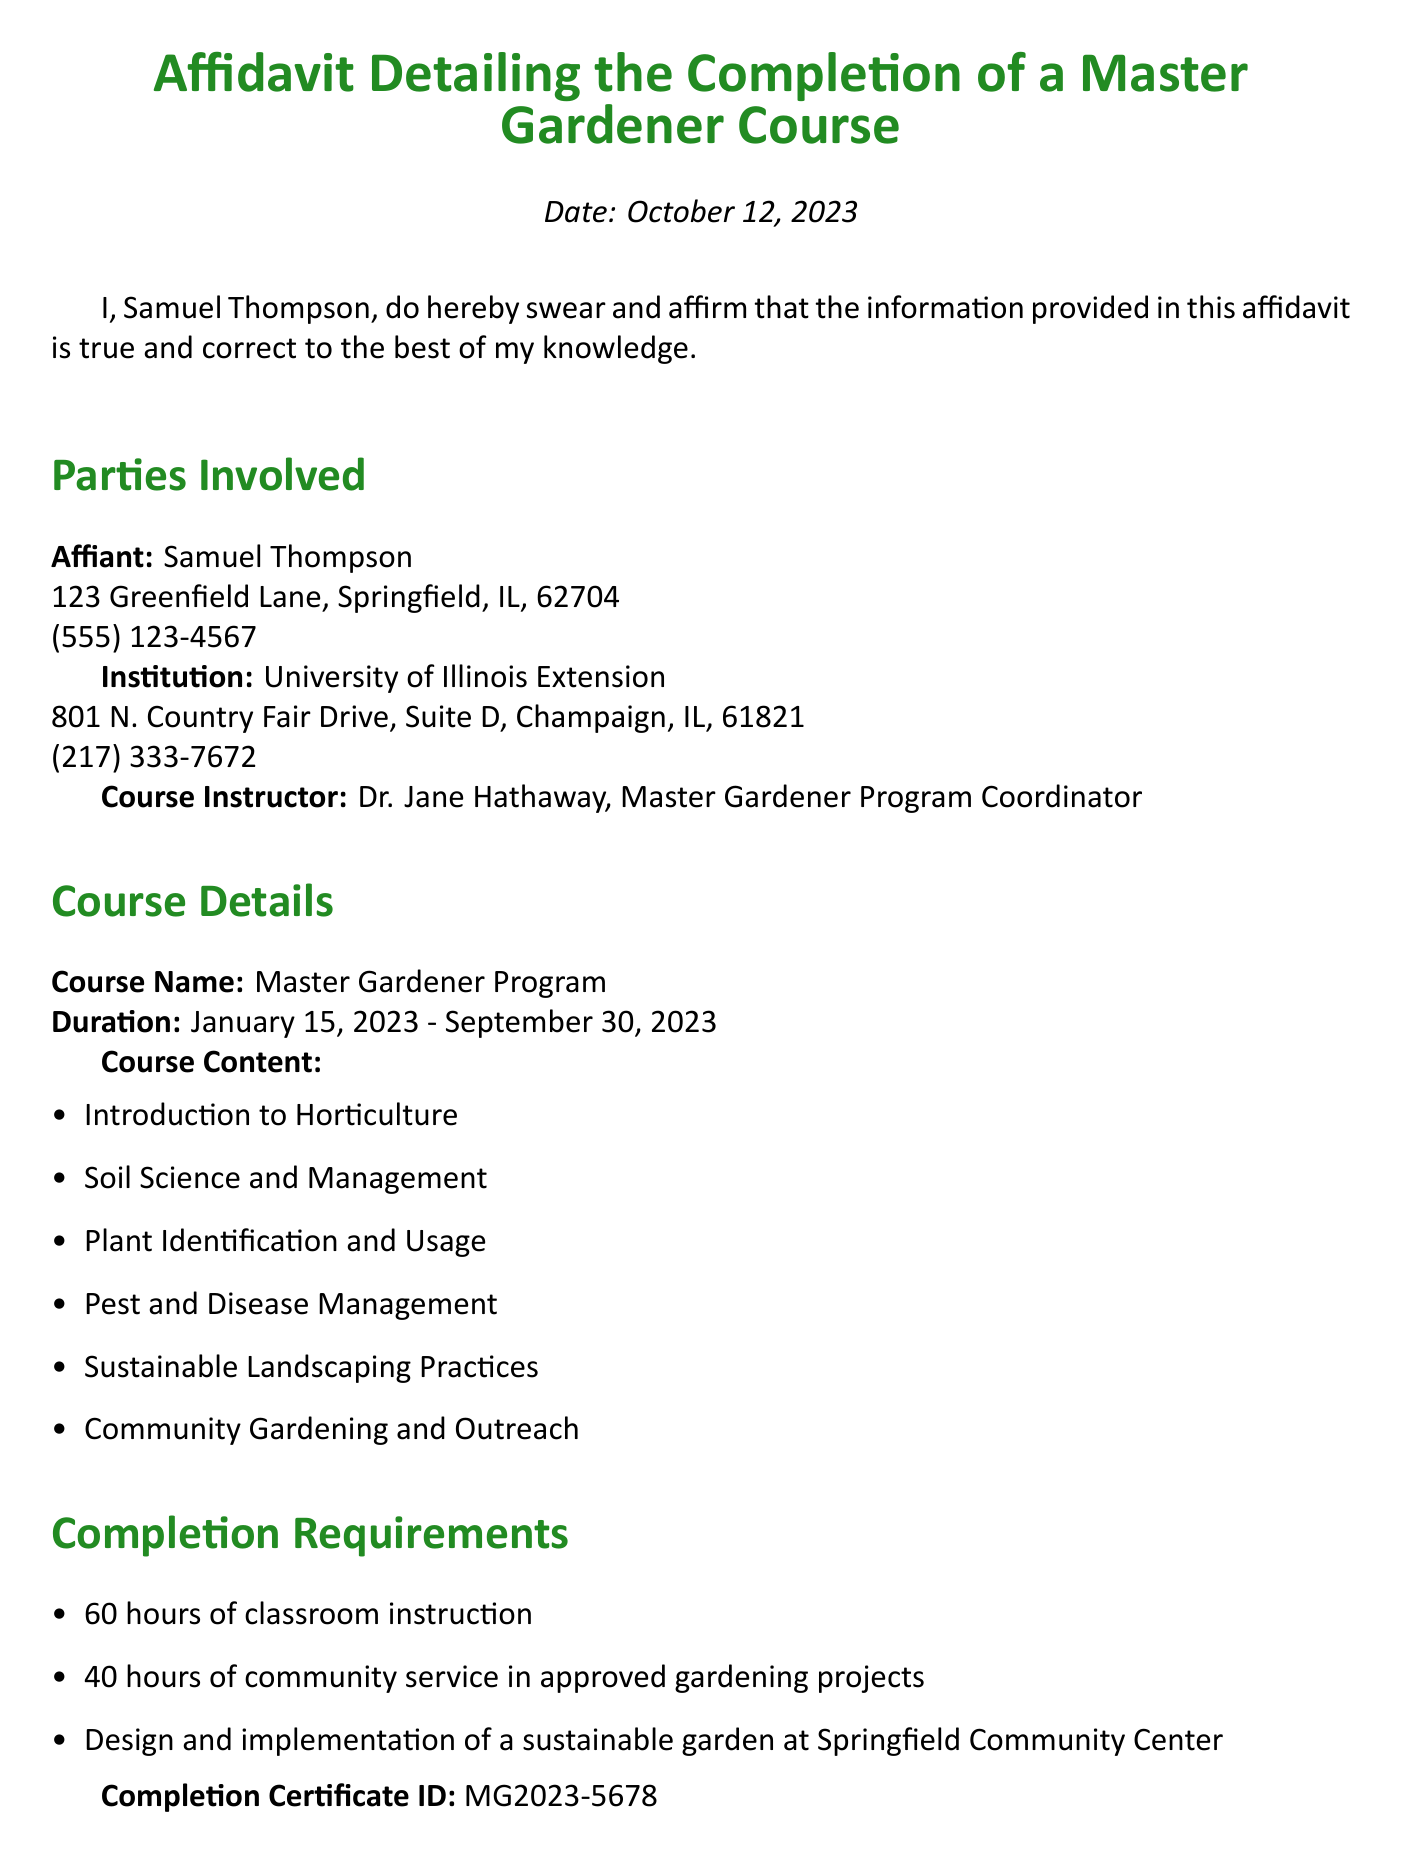What is the name of the affiant? The affiant is the individual who swears the affidavit; in this case, it is Samuel Thompson.
Answer: Samuel Thompson What is the completion certificate ID? The completion certificate ID is a unique identifier for the completion of the course issued, which is used for validation purposes.
Answer: MG2023-5678 When did the Master Gardener Program course start? The start date of the course is crucial for understanding the timeline of the training received.
Answer: January 15, 2023 Who was the course instructor? The course instructor's name is important for recognizing the authority and expertise behind the program.
Answer: Dr. Jane Hathaway How many hours of classroom instruction were required? The total hours indicate the commitment needed to complete the course successfully.
Answer: 60 hours What was one of the community service requirements? Community service is a critical aspect of practical learning, indicating the program's emphasis on hands-on experience.
Answer: 40 hours of community service in approved gardening projects What is the end date of the course? Identifying the end date helps to understand the overall duration of the program.
Answer: September 30, 2023 What institution conducted the Master Gardener Program? Knowing the institution allows for the verification of the program's credibility and resources.
Answer: University of Illinois Extension What is the declaration statement? The declaration statement sums up the legal affirmation made by the affiant regarding the truthfulness of the document.
Answer: I declare under penalty of perjury under the laws of the State of Illinois that the foregoing is true and correct 